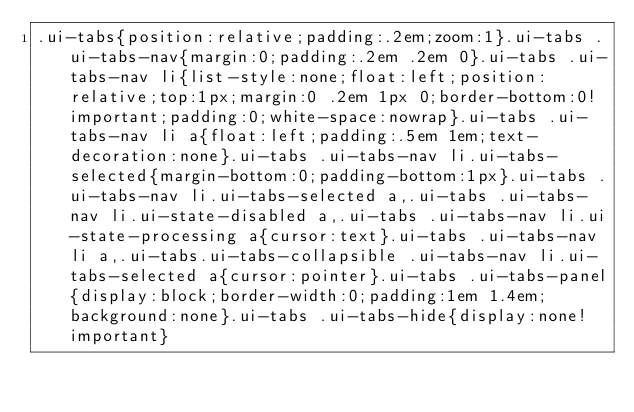<code> <loc_0><loc_0><loc_500><loc_500><_CSS_>.ui-tabs{position:relative;padding:.2em;zoom:1}.ui-tabs .ui-tabs-nav{margin:0;padding:.2em .2em 0}.ui-tabs .ui-tabs-nav li{list-style:none;float:left;position:relative;top:1px;margin:0 .2em 1px 0;border-bottom:0!important;padding:0;white-space:nowrap}.ui-tabs .ui-tabs-nav li a{float:left;padding:.5em 1em;text-decoration:none}.ui-tabs .ui-tabs-nav li.ui-tabs-selected{margin-bottom:0;padding-bottom:1px}.ui-tabs .ui-tabs-nav li.ui-tabs-selected a,.ui-tabs .ui-tabs-nav li.ui-state-disabled a,.ui-tabs .ui-tabs-nav li.ui-state-processing a{cursor:text}.ui-tabs .ui-tabs-nav li a,.ui-tabs.ui-tabs-collapsible .ui-tabs-nav li.ui-tabs-selected a{cursor:pointer}.ui-tabs .ui-tabs-panel{display:block;border-width:0;padding:1em 1.4em;background:none}.ui-tabs .ui-tabs-hide{display:none!important}</code> 